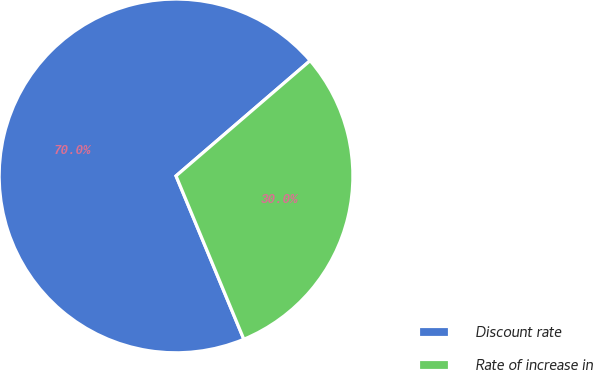Convert chart to OTSL. <chart><loc_0><loc_0><loc_500><loc_500><pie_chart><fcel>Discount rate<fcel>Rate of increase in<nl><fcel>69.96%<fcel>30.04%<nl></chart> 